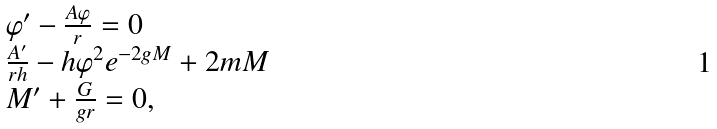<formula> <loc_0><loc_0><loc_500><loc_500>\begin{array} { l l } { { \varphi ^ { \prime } - \frac { A \varphi } { r } = 0 } } \\ { { \frac { A ^ { \prime } } { r h } - h \varphi ^ { 2 } e ^ { - 2 g M } + 2 m M } } \\ { { M ^ { \prime } + \frac { G } { g r } = 0 , } } \end{array}</formula> 